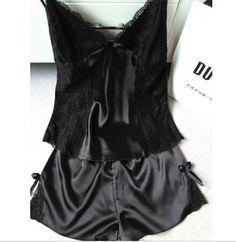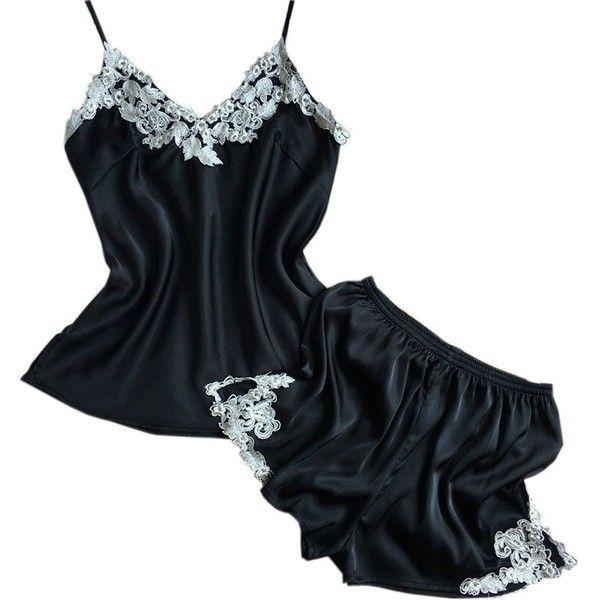The first image is the image on the left, the second image is the image on the right. Examine the images to the left and right. Is the description "In one image, a woman is wearing a black pajama set that is comprised of shorts and a camisole top" accurate? Answer yes or no. No. The first image is the image on the left, the second image is the image on the right. Examine the images to the left and right. Is the description "One image contains a women wearing black sleep attire." accurate? Answer yes or no. No. 